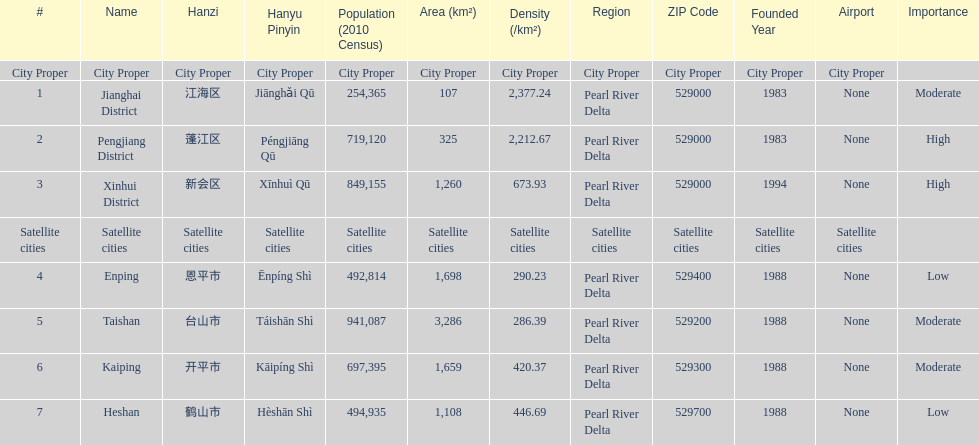What city proper has the smallest area in km2? Jianghai District. 